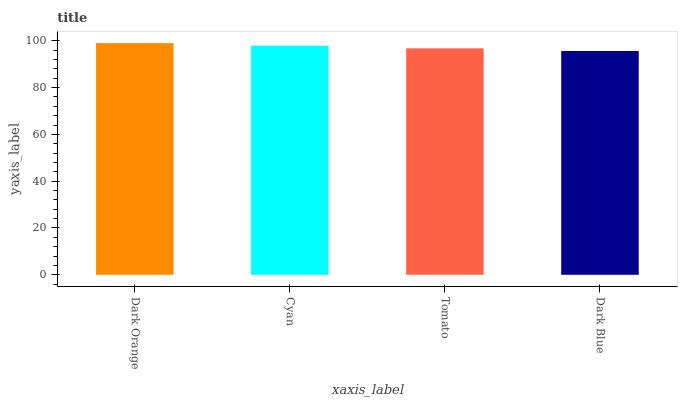Is Dark Blue the minimum?
Answer yes or no. Yes. Is Dark Orange the maximum?
Answer yes or no. Yes. Is Cyan the minimum?
Answer yes or no. No. Is Cyan the maximum?
Answer yes or no. No. Is Dark Orange greater than Cyan?
Answer yes or no. Yes. Is Cyan less than Dark Orange?
Answer yes or no. Yes. Is Cyan greater than Dark Orange?
Answer yes or no. No. Is Dark Orange less than Cyan?
Answer yes or no. No. Is Cyan the high median?
Answer yes or no. Yes. Is Tomato the low median?
Answer yes or no. Yes. Is Dark Blue the high median?
Answer yes or no. No. Is Cyan the low median?
Answer yes or no. No. 